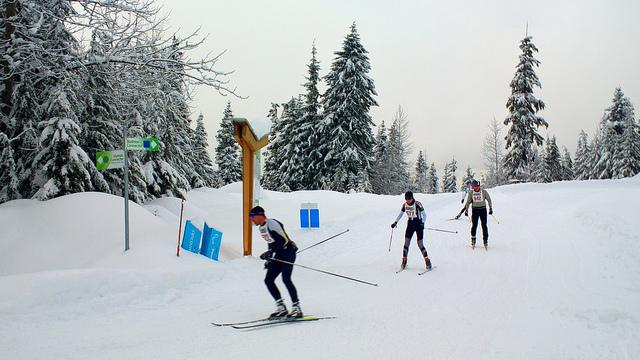Where was modern skiing invented? scandinavia 